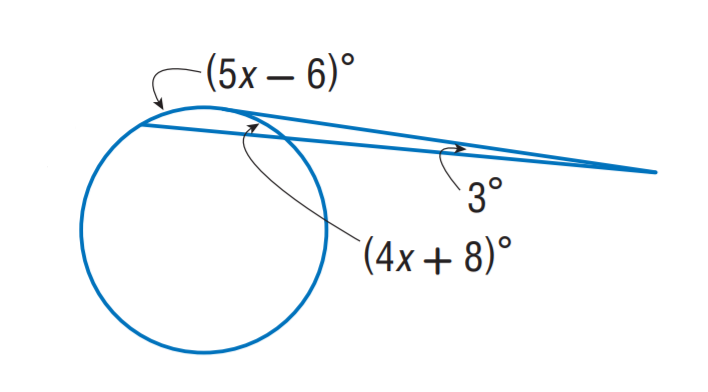Answer the mathemtical geometry problem and directly provide the correct option letter.
Question: Find x.
Choices: A: 10 B: 15 C: 20 D: 25 C 